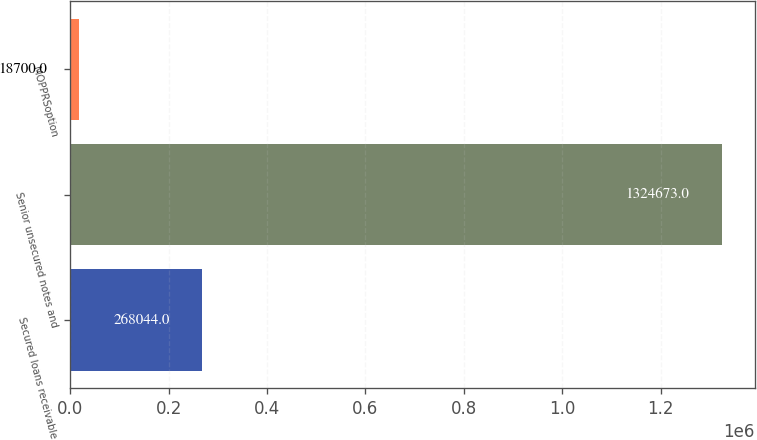Convert chart. <chart><loc_0><loc_0><loc_500><loc_500><bar_chart><fcel>Secured loans receivable<fcel>Senior unsecured notes and<fcel>MOPPRSoption<nl><fcel>268044<fcel>1.32467e+06<fcel>18700<nl></chart> 